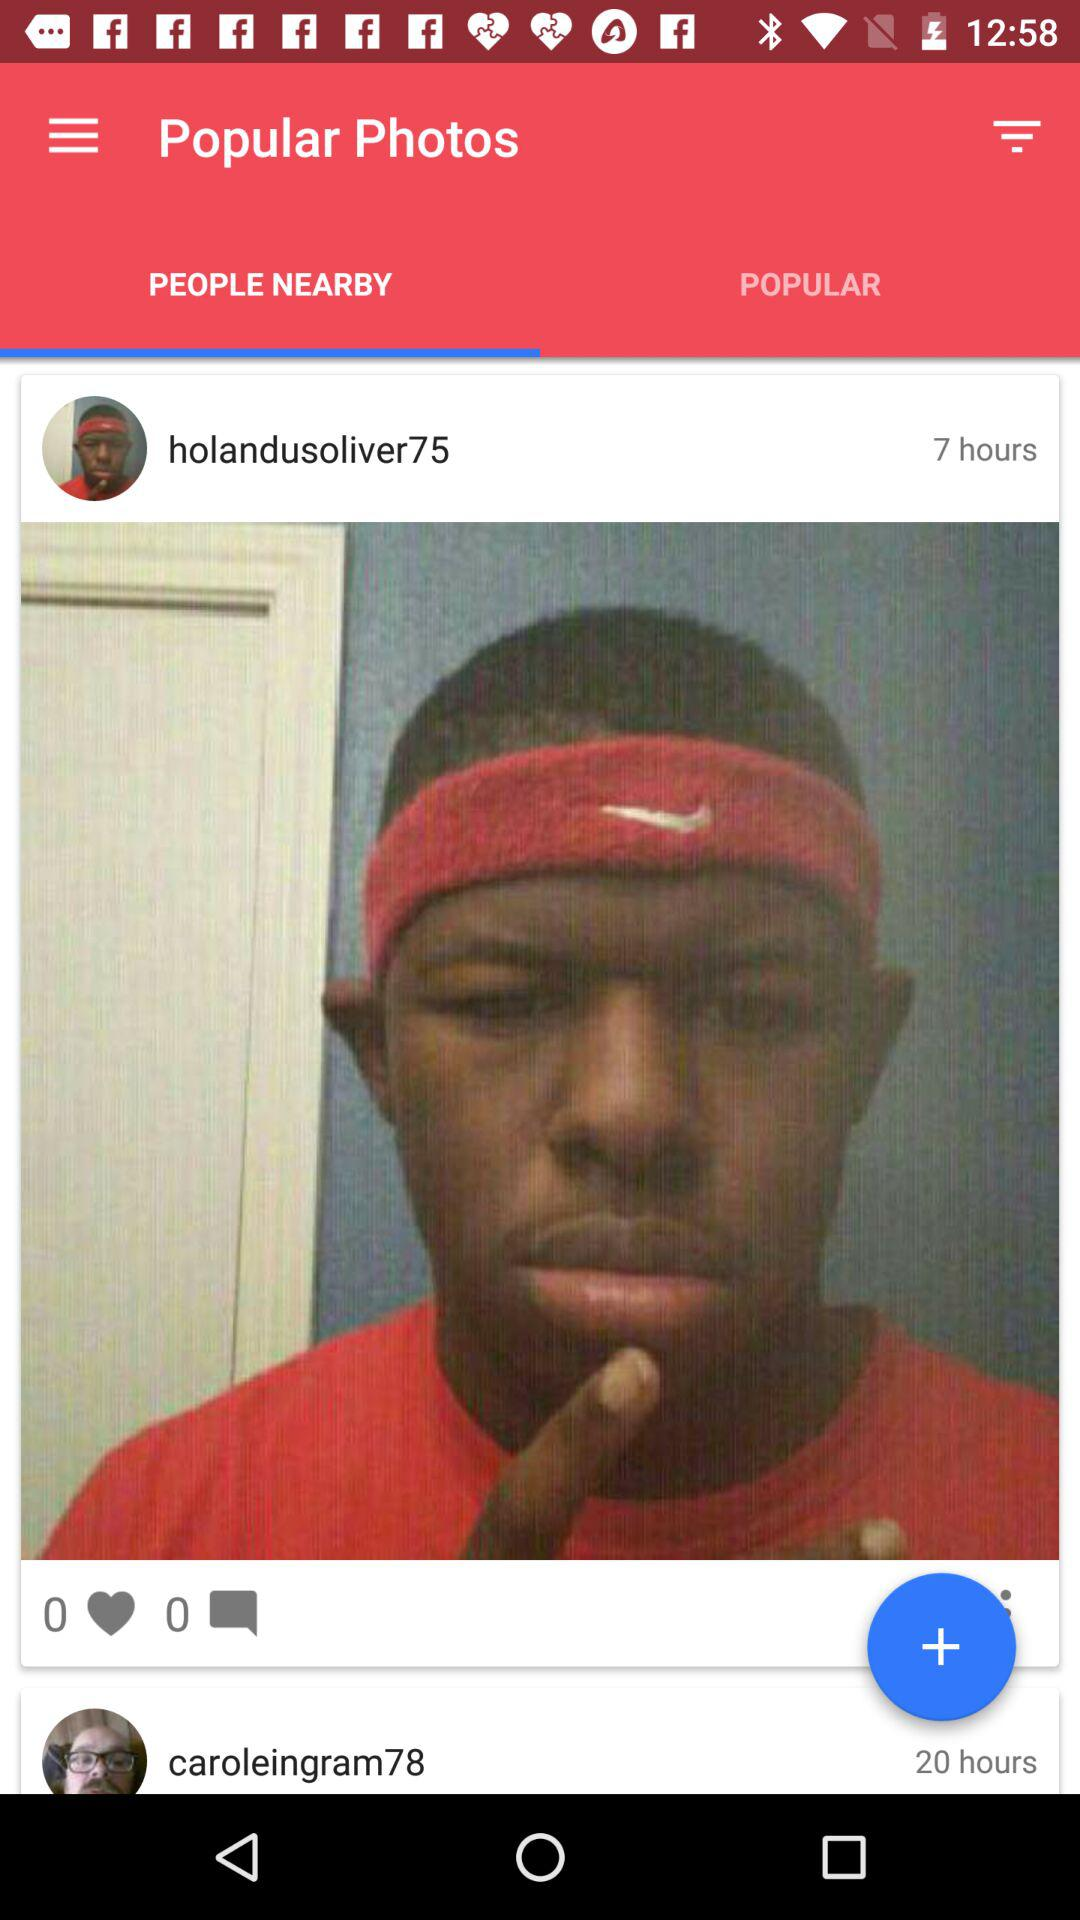How many hearts did "holandusoliver75" get? "holandusoliver75" got 0 hearts. 